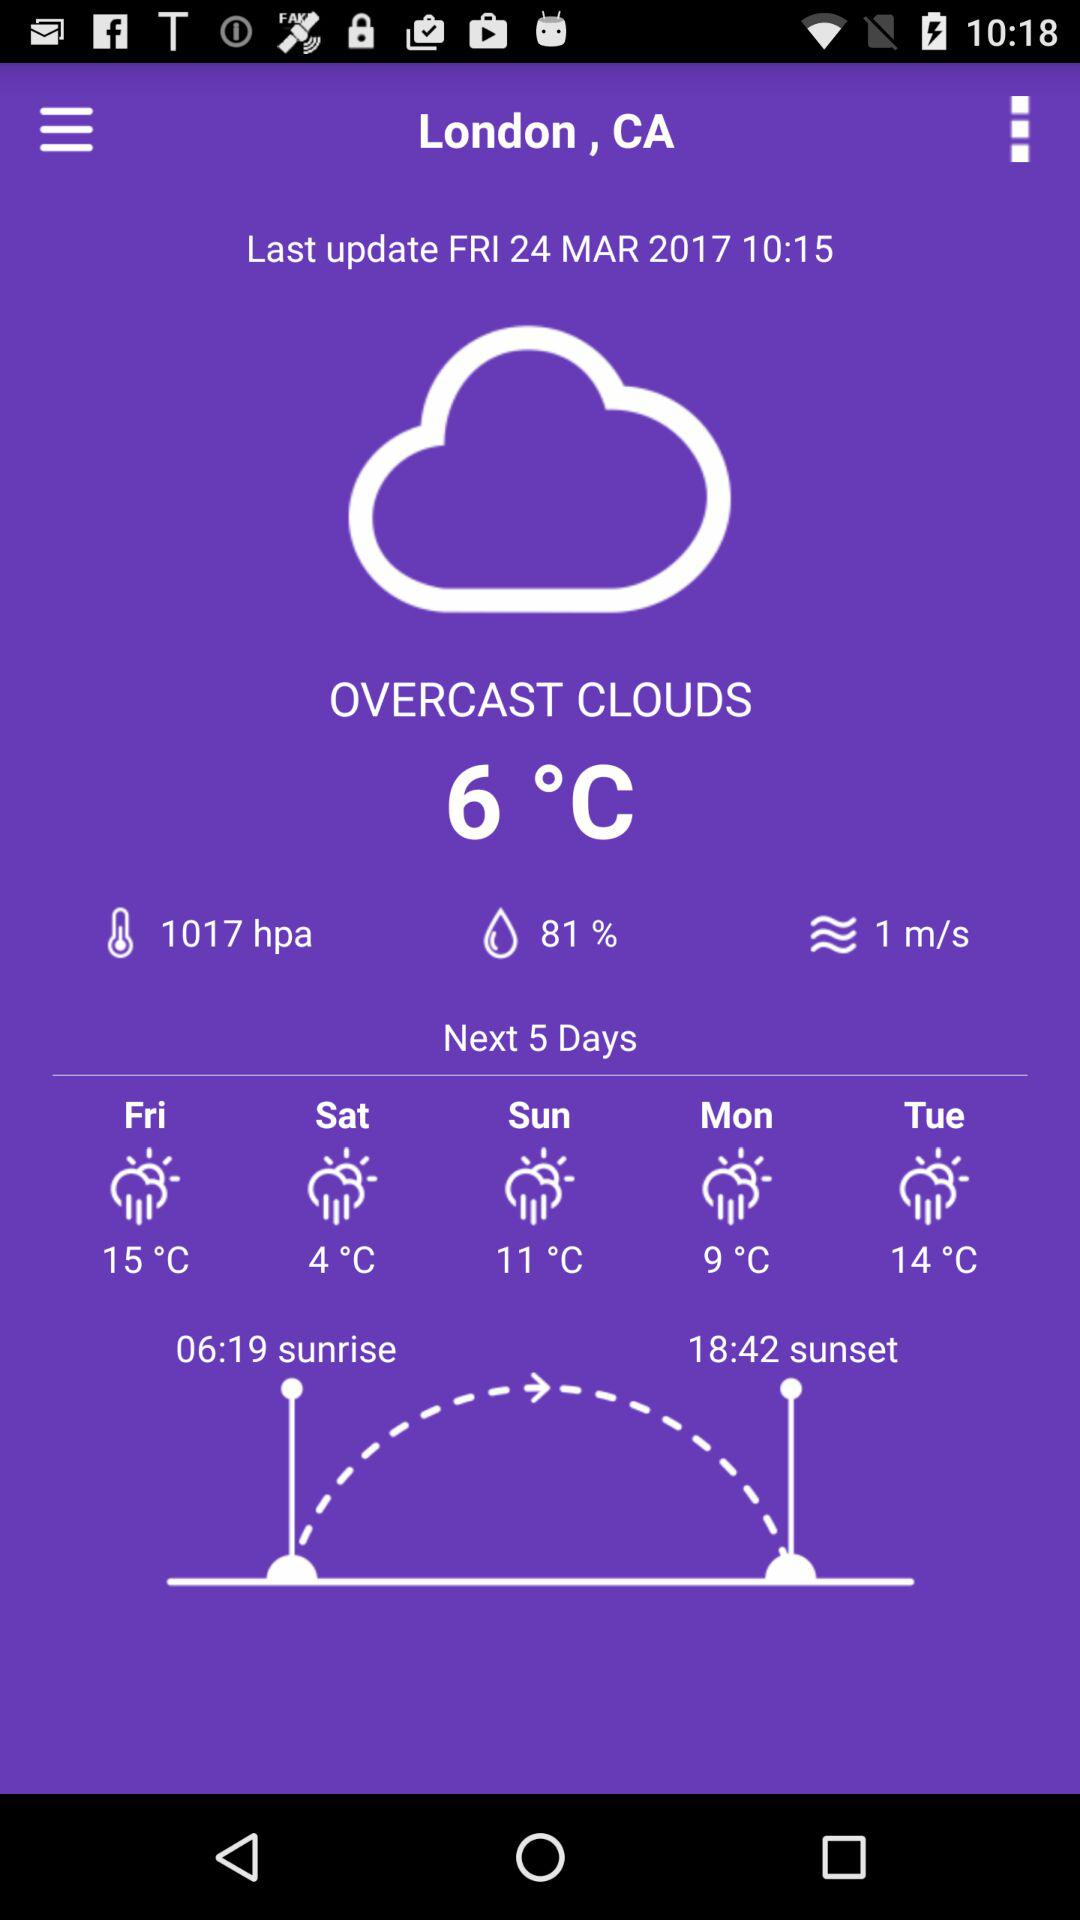What is the last updated time? The last updated time is 10:15. 